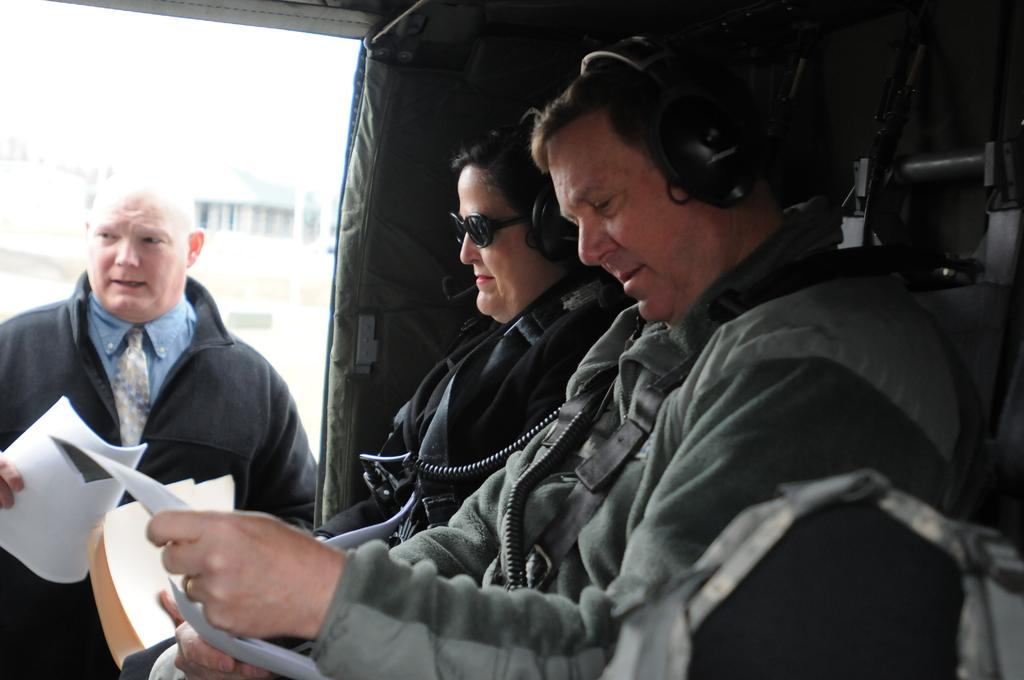How many people are present in the image? There are three people in the image. What are the people wearing? All three people are wearing clothes. What type of accessory are two of the people wearing? Two of the people are wearing headsets. What are the people holding in their hands? The people are holding papers in their hands. What type of hall can be seen in the background of the image? There is no hall visible in the background of the image. 